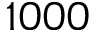<formula> <loc_0><loc_0><loc_500><loc_500>1 0 0 0</formula> 